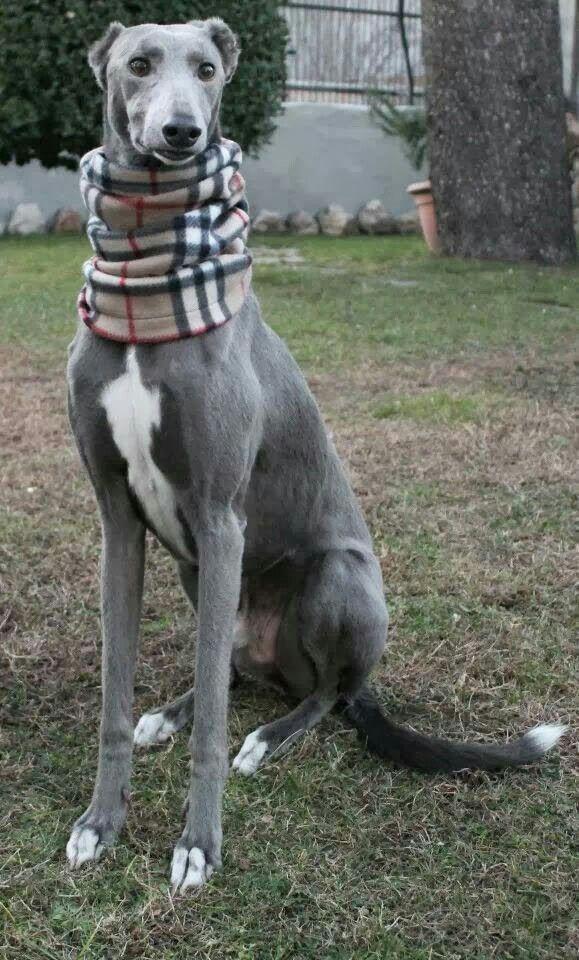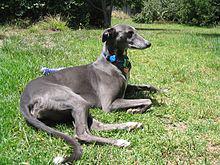The first image is the image on the left, the second image is the image on the right. Assess this claim about the two images: "A hound wears a turtle-neck wrap in one image, and the other image shows a hound wearing a dog collar.". Correct or not? Answer yes or no. Yes. The first image is the image on the left, the second image is the image on the right. Given the left and right images, does the statement "At least one of the dogs in the image on the left is standing on all four legs." hold true? Answer yes or no. No. 